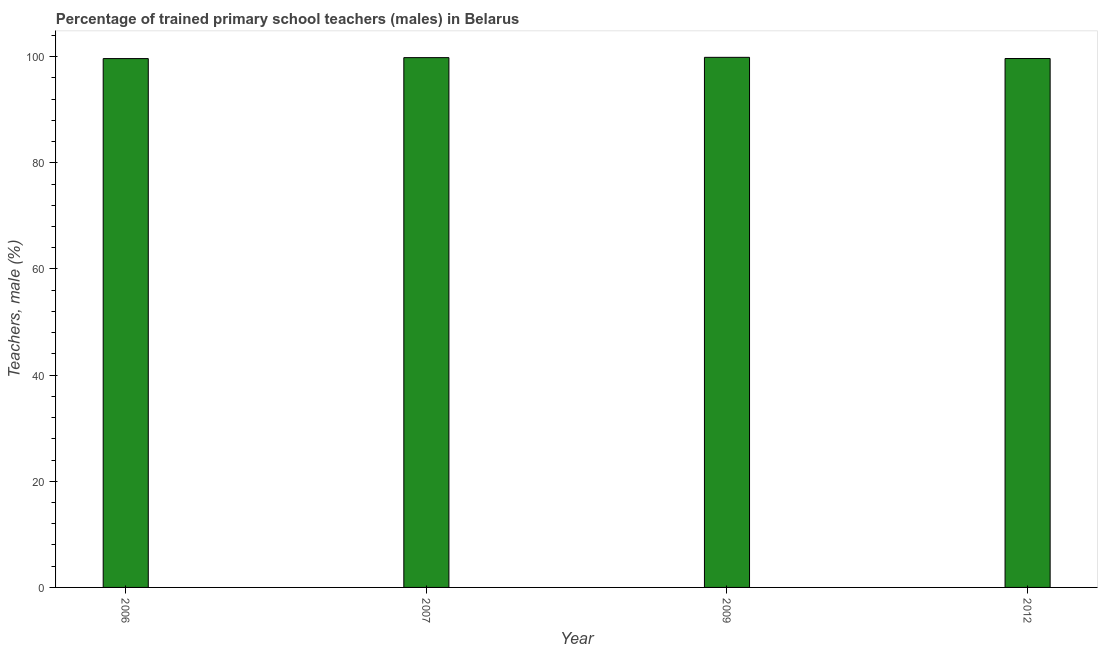Does the graph contain any zero values?
Keep it short and to the point. No. What is the title of the graph?
Provide a short and direct response. Percentage of trained primary school teachers (males) in Belarus. What is the label or title of the Y-axis?
Keep it short and to the point. Teachers, male (%). What is the percentage of trained male teachers in 2012?
Offer a terse response. 99.64. Across all years, what is the maximum percentage of trained male teachers?
Keep it short and to the point. 99.87. Across all years, what is the minimum percentage of trained male teachers?
Provide a succinct answer. 99.63. In which year was the percentage of trained male teachers maximum?
Keep it short and to the point. 2009. What is the sum of the percentage of trained male teachers?
Offer a very short reply. 398.94. What is the difference between the percentage of trained male teachers in 2006 and 2007?
Offer a very short reply. -0.18. What is the average percentage of trained male teachers per year?
Provide a succinct answer. 99.74. What is the median percentage of trained male teachers?
Offer a very short reply. 99.73. Do a majority of the years between 2006 and 2007 (inclusive) have percentage of trained male teachers greater than 44 %?
Keep it short and to the point. Yes. What is the ratio of the percentage of trained male teachers in 2006 to that in 2012?
Your response must be concise. 1. What is the difference between the highest and the second highest percentage of trained male teachers?
Your answer should be very brief. 0.06. What is the difference between the highest and the lowest percentage of trained male teachers?
Provide a succinct answer. 0.24. Are all the bars in the graph horizontal?
Offer a terse response. No. Are the values on the major ticks of Y-axis written in scientific E-notation?
Ensure brevity in your answer.  No. What is the Teachers, male (%) of 2006?
Provide a succinct answer. 99.63. What is the Teachers, male (%) in 2007?
Provide a short and direct response. 99.81. What is the Teachers, male (%) of 2009?
Make the answer very short. 99.87. What is the Teachers, male (%) of 2012?
Give a very brief answer. 99.64. What is the difference between the Teachers, male (%) in 2006 and 2007?
Make the answer very short. -0.18. What is the difference between the Teachers, male (%) in 2006 and 2009?
Ensure brevity in your answer.  -0.24. What is the difference between the Teachers, male (%) in 2006 and 2012?
Your answer should be very brief. -0.01. What is the difference between the Teachers, male (%) in 2007 and 2009?
Ensure brevity in your answer.  -0.06. What is the difference between the Teachers, male (%) in 2007 and 2012?
Your answer should be very brief. 0.17. What is the difference between the Teachers, male (%) in 2009 and 2012?
Your answer should be compact. 0.22. What is the ratio of the Teachers, male (%) in 2006 to that in 2007?
Ensure brevity in your answer.  1. What is the ratio of the Teachers, male (%) in 2006 to that in 2009?
Give a very brief answer. 1. What is the ratio of the Teachers, male (%) in 2007 to that in 2009?
Ensure brevity in your answer.  1. What is the ratio of the Teachers, male (%) in 2007 to that in 2012?
Give a very brief answer. 1. 